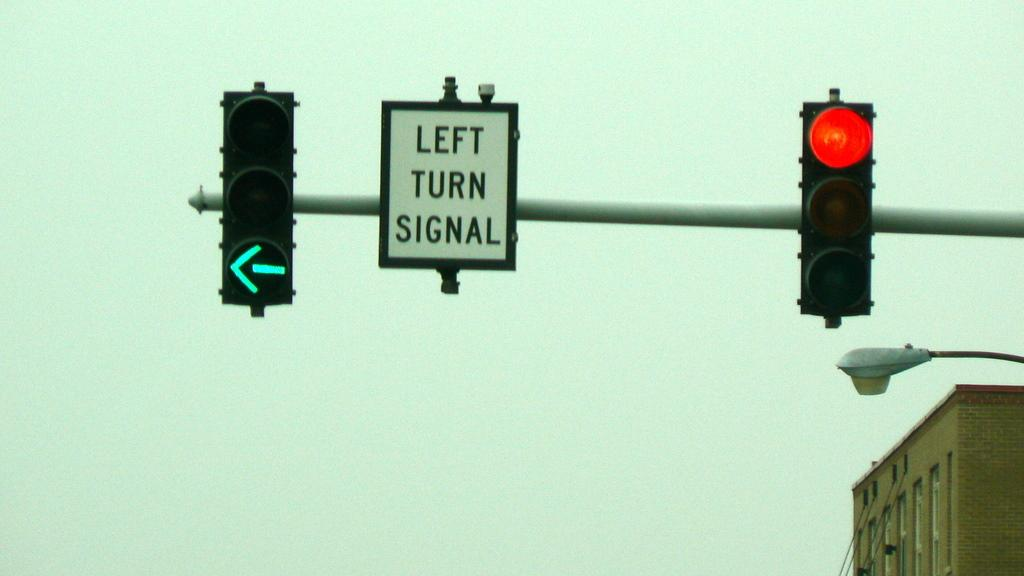<image>
Render a clear and concise summary of the photo. A red light is  to the right of a sign reading Left Turn Signal. 